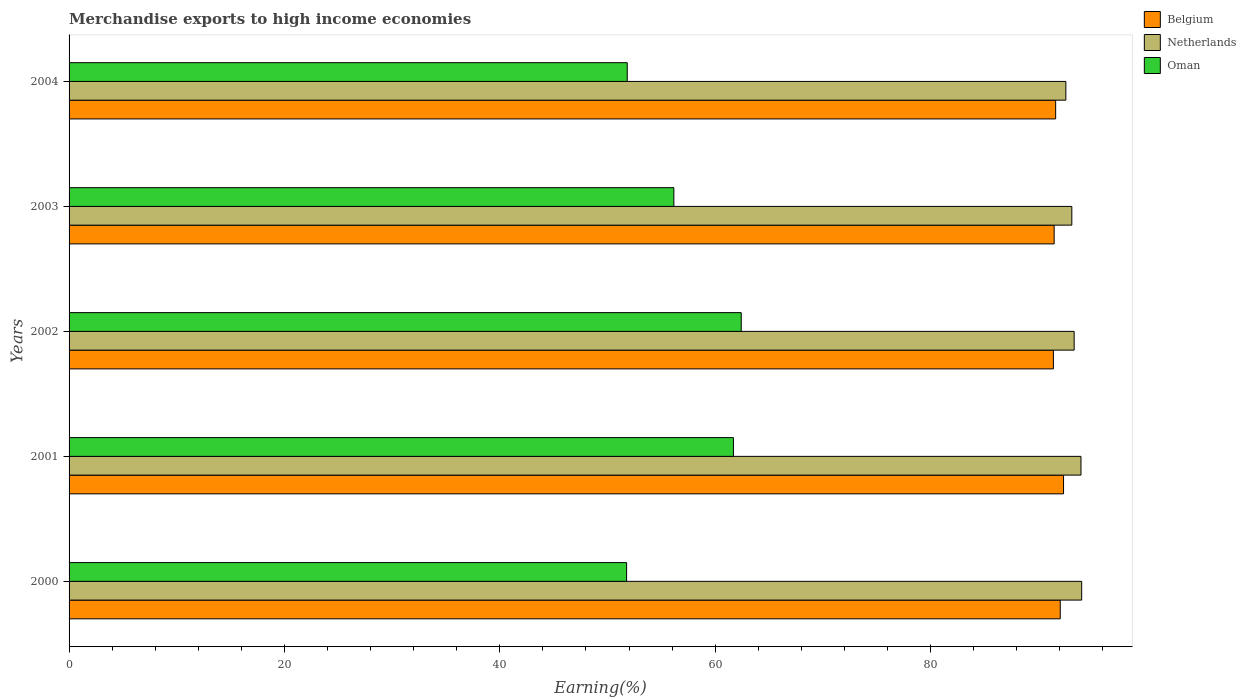How many groups of bars are there?
Offer a terse response. 5. Are the number of bars on each tick of the Y-axis equal?
Ensure brevity in your answer.  Yes. How many bars are there on the 4th tick from the bottom?
Offer a terse response. 3. What is the percentage of amount earned from merchandise exports in Belgium in 2003?
Provide a succinct answer. 91.47. Across all years, what is the maximum percentage of amount earned from merchandise exports in Oman?
Provide a short and direct response. 62.42. Across all years, what is the minimum percentage of amount earned from merchandise exports in Belgium?
Keep it short and to the point. 91.4. In which year was the percentage of amount earned from merchandise exports in Netherlands minimum?
Give a very brief answer. 2004. What is the total percentage of amount earned from merchandise exports in Oman in the graph?
Your answer should be very brief. 283.87. What is the difference between the percentage of amount earned from merchandise exports in Oman in 2000 and that in 2003?
Offer a terse response. -4.39. What is the difference between the percentage of amount earned from merchandise exports in Oman in 2000 and the percentage of amount earned from merchandise exports in Netherlands in 2001?
Your answer should be very brief. -42.19. What is the average percentage of amount earned from merchandise exports in Netherlands per year?
Your answer should be compact. 93.4. In the year 2004, what is the difference between the percentage of amount earned from merchandise exports in Netherlands and percentage of amount earned from merchandise exports in Belgium?
Provide a short and direct response. 0.95. In how many years, is the percentage of amount earned from merchandise exports in Oman greater than 28 %?
Provide a short and direct response. 5. What is the ratio of the percentage of amount earned from merchandise exports in Oman in 2003 to that in 2004?
Provide a succinct answer. 1.08. Is the percentage of amount earned from merchandise exports in Oman in 2000 less than that in 2003?
Provide a short and direct response. Yes. What is the difference between the highest and the second highest percentage of amount earned from merchandise exports in Netherlands?
Offer a very short reply. 0.07. What is the difference between the highest and the lowest percentage of amount earned from merchandise exports in Netherlands?
Your answer should be very brief. 1.47. In how many years, is the percentage of amount earned from merchandise exports in Belgium greater than the average percentage of amount earned from merchandise exports in Belgium taken over all years?
Offer a terse response. 2. Is the sum of the percentage of amount earned from merchandise exports in Belgium in 2003 and 2004 greater than the maximum percentage of amount earned from merchandise exports in Netherlands across all years?
Keep it short and to the point. Yes. What does the 1st bar from the top in 2000 represents?
Provide a succinct answer. Oman. What does the 2nd bar from the bottom in 2001 represents?
Provide a succinct answer. Netherlands. Is it the case that in every year, the sum of the percentage of amount earned from merchandise exports in Belgium and percentage of amount earned from merchandise exports in Netherlands is greater than the percentage of amount earned from merchandise exports in Oman?
Offer a terse response. Yes. How many bars are there?
Your answer should be very brief. 15. Are all the bars in the graph horizontal?
Ensure brevity in your answer.  Yes. How many years are there in the graph?
Offer a very short reply. 5. Are the values on the major ticks of X-axis written in scientific E-notation?
Make the answer very short. No. Does the graph contain any zero values?
Offer a terse response. No. Where does the legend appear in the graph?
Keep it short and to the point. Top right. How are the legend labels stacked?
Your answer should be compact. Vertical. What is the title of the graph?
Give a very brief answer. Merchandise exports to high income economies. Does "Bulgaria" appear as one of the legend labels in the graph?
Provide a short and direct response. No. What is the label or title of the X-axis?
Your response must be concise. Earning(%). What is the label or title of the Y-axis?
Your response must be concise. Years. What is the Earning(%) in Belgium in 2000?
Offer a very short reply. 92.04. What is the Earning(%) in Netherlands in 2000?
Ensure brevity in your answer.  94.03. What is the Earning(%) of Oman in 2000?
Provide a succinct answer. 51.77. What is the Earning(%) of Belgium in 2001?
Offer a very short reply. 92.35. What is the Earning(%) of Netherlands in 2001?
Provide a succinct answer. 93.96. What is the Earning(%) of Oman in 2001?
Provide a short and direct response. 61.69. What is the Earning(%) of Belgium in 2002?
Your response must be concise. 91.4. What is the Earning(%) of Netherlands in 2002?
Make the answer very short. 93.33. What is the Earning(%) of Oman in 2002?
Your answer should be compact. 62.42. What is the Earning(%) in Belgium in 2003?
Offer a terse response. 91.47. What is the Earning(%) of Netherlands in 2003?
Keep it short and to the point. 93.11. What is the Earning(%) of Oman in 2003?
Offer a very short reply. 56.16. What is the Earning(%) of Belgium in 2004?
Provide a succinct answer. 91.61. What is the Earning(%) of Netherlands in 2004?
Make the answer very short. 92.56. What is the Earning(%) of Oman in 2004?
Your answer should be very brief. 51.83. Across all years, what is the maximum Earning(%) of Belgium?
Make the answer very short. 92.35. Across all years, what is the maximum Earning(%) of Netherlands?
Offer a terse response. 94.03. Across all years, what is the maximum Earning(%) in Oman?
Keep it short and to the point. 62.42. Across all years, what is the minimum Earning(%) in Belgium?
Provide a short and direct response. 91.4. Across all years, what is the minimum Earning(%) in Netherlands?
Your answer should be very brief. 92.56. Across all years, what is the minimum Earning(%) of Oman?
Ensure brevity in your answer.  51.77. What is the total Earning(%) in Belgium in the graph?
Give a very brief answer. 458.87. What is the total Earning(%) of Netherlands in the graph?
Make the answer very short. 467. What is the total Earning(%) of Oman in the graph?
Your response must be concise. 283.87. What is the difference between the Earning(%) in Belgium in 2000 and that in 2001?
Make the answer very short. -0.31. What is the difference between the Earning(%) of Netherlands in 2000 and that in 2001?
Provide a succinct answer. 0.07. What is the difference between the Earning(%) of Oman in 2000 and that in 2001?
Provide a short and direct response. -9.92. What is the difference between the Earning(%) of Belgium in 2000 and that in 2002?
Give a very brief answer. 0.64. What is the difference between the Earning(%) in Netherlands in 2000 and that in 2002?
Provide a short and direct response. 0.7. What is the difference between the Earning(%) of Oman in 2000 and that in 2002?
Provide a short and direct response. -10.64. What is the difference between the Earning(%) in Belgium in 2000 and that in 2003?
Provide a short and direct response. 0.57. What is the difference between the Earning(%) of Netherlands in 2000 and that in 2003?
Ensure brevity in your answer.  0.92. What is the difference between the Earning(%) in Oman in 2000 and that in 2003?
Keep it short and to the point. -4.39. What is the difference between the Earning(%) of Belgium in 2000 and that in 2004?
Offer a terse response. 0.43. What is the difference between the Earning(%) in Netherlands in 2000 and that in 2004?
Ensure brevity in your answer.  1.47. What is the difference between the Earning(%) in Oman in 2000 and that in 2004?
Your answer should be compact. -0.06. What is the difference between the Earning(%) in Belgium in 2001 and that in 2002?
Your answer should be very brief. 0.94. What is the difference between the Earning(%) of Netherlands in 2001 and that in 2002?
Ensure brevity in your answer.  0.63. What is the difference between the Earning(%) in Oman in 2001 and that in 2002?
Offer a very short reply. -0.73. What is the difference between the Earning(%) in Belgium in 2001 and that in 2003?
Your response must be concise. 0.87. What is the difference between the Earning(%) in Netherlands in 2001 and that in 2003?
Provide a succinct answer. 0.85. What is the difference between the Earning(%) of Oman in 2001 and that in 2003?
Ensure brevity in your answer.  5.53. What is the difference between the Earning(%) in Belgium in 2001 and that in 2004?
Give a very brief answer. 0.73. What is the difference between the Earning(%) in Netherlands in 2001 and that in 2004?
Your answer should be compact. 1.4. What is the difference between the Earning(%) in Oman in 2001 and that in 2004?
Your response must be concise. 9.86. What is the difference between the Earning(%) in Belgium in 2002 and that in 2003?
Offer a terse response. -0.07. What is the difference between the Earning(%) in Netherlands in 2002 and that in 2003?
Give a very brief answer. 0.22. What is the difference between the Earning(%) of Oman in 2002 and that in 2003?
Provide a short and direct response. 6.26. What is the difference between the Earning(%) in Belgium in 2002 and that in 2004?
Your answer should be compact. -0.21. What is the difference between the Earning(%) in Netherlands in 2002 and that in 2004?
Your answer should be very brief. 0.77. What is the difference between the Earning(%) in Oman in 2002 and that in 2004?
Your response must be concise. 10.59. What is the difference between the Earning(%) in Belgium in 2003 and that in 2004?
Make the answer very short. -0.14. What is the difference between the Earning(%) in Netherlands in 2003 and that in 2004?
Provide a short and direct response. 0.55. What is the difference between the Earning(%) in Oman in 2003 and that in 2004?
Your answer should be very brief. 4.33. What is the difference between the Earning(%) of Belgium in 2000 and the Earning(%) of Netherlands in 2001?
Offer a very short reply. -1.92. What is the difference between the Earning(%) of Belgium in 2000 and the Earning(%) of Oman in 2001?
Your answer should be very brief. 30.35. What is the difference between the Earning(%) in Netherlands in 2000 and the Earning(%) in Oman in 2001?
Offer a terse response. 32.34. What is the difference between the Earning(%) in Belgium in 2000 and the Earning(%) in Netherlands in 2002?
Your answer should be very brief. -1.29. What is the difference between the Earning(%) in Belgium in 2000 and the Earning(%) in Oman in 2002?
Provide a succinct answer. 29.62. What is the difference between the Earning(%) in Netherlands in 2000 and the Earning(%) in Oman in 2002?
Provide a succinct answer. 31.61. What is the difference between the Earning(%) in Belgium in 2000 and the Earning(%) in Netherlands in 2003?
Keep it short and to the point. -1.07. What is the difference between the Earning(%) in Belgium in 2000 and the Earning(%) in Oman in 2003?
Provide a succinct answer. 35.88. What is the difference between the Earning(%) of Netherlands in 2000 and the Earning(%) of Oman in 2003?
Your answer should be compact. 37.87. What is the difference between the Earning(%) of Belgium in 2000 and the Earning(%) of Netherlands in 2004?
Your answer should be very brief. -0.52. What is the difference between the Earning(%) in Belgium in 2000 and the Earning(%) in Oman in 2004?
Offer a terse response. 40.21. What is the difference between the Earning(%) in Netherlands in 2000 and the Earning(%) in Oman in 2004?
Make the answer very short. 42.2. What is the difference between the Earning(%) of Belgium in 2001 and the Earning(%) of Netherlands in 2002?
Your answer should be very brief. -0.98. What is the difference between the Earning(%) in Belgium in 2001 and the Earning(%) in Oman in 2002?
Offer a terse response. 29.93. What is the difference between the Earning(%) in Netherlands in 2001 and the Earning(%) in Oman in 2002?
Provide a short and direct response. 31.55. What is the difference between the Earning(%) in Belgium in 2001 and the Earning(%) in Netherlands in 2003?
Offer a terse response. -0.77. What is the difference between the Earning(%) of Belgium in 2001 and the Earning(%) of Oman in 2003?
Give a very brief answer. 36.19. What is the difference between the Earning(%) in Netherlands in 2001 and the Earning(%) in Oman in 2003?
Offer a terse response. 37.8. What is the difference between the Earning(%) of Belgium in 2001 and the Earning(%) of Netherlands in 2004?
Provide a short and direct response. -0.21. What is the difference between the Earning(%) of Belgium in 2001 and the Earning(%) of Oman in 2004?
Offer a very short reply. 40.51. What is the difference between the Earning(%) in Netherlands in 2001 and the Earning(%) in Oman in 2004?
Offer a terse response. 42.13. What is the difference between the Earning(%) in Belgium in 2002 and the Earning(%) in Netherlands in 2003?
Offer a very short reply. -1.71. What is the difference between the Earning(%) of Belgium in 2002 and the Earning(%) of Oman in 2003?
Ensure brevity in your answer.  35.24. What is the difference between the Earning(%) of Netherlands in 2002 and the Earning(%) of Oman in 2003?
Offer a terse response. 37.17. What is the difference between the Earning(%) in Belgium in 2002 and the Earning(%) in Netherlands in 2004?
Give a very brief answer. -1.16. What is the difference between the Earning(%) of Belgium in 2002 and the Earning(%) of Oman in 2004?
Provide a short and direct response. 39.57. What is the difference between the Earning(%) in Netherlands in 2002 and the Earning(%) in Oman in 2004?
Your answer should be very brief. 41.5. What is the difference between the Earning(%) in Belgium in 2003 and the Earning(%) in Netherlands in 2004?
Keep it short and to the point. -1.09. What is the difference between the Earning(%) in Belgium in 2003 and the Earning(%) in Oman in 2004?
Give a very brief answer. 39.64. What is the difference between the Earning(%) in Netherlands in 2003 and the Earning(%) in Oman in 2004?
Ensure brevity in your answer.  41.28. What is the average Earning(%) in Belgium per year?
Your answer should be compact. 91.77. What is the average Earning(%) of Netherlands per year?
Offer a very short reply. 93.4. What is the average Earning(%) of Oman per year?
Ensure brevity in your answer.  56.77. In the year 2000, what is the difference between the Earning(%) in Belgium and Earning(%) in Netherlands?
Make the answer very short. -1.99. In the year 2000, what is the difference between the Earning(%) of Belgium and Earning(%) of Oman?
Keep it short and to the point. 40.27. In the year 2000, what is the difference between the Earning(%) in Netherlands and Earning(%) in Oman?
Offer a very short reply. 42.26. In the year 2001, what is the difference between the Earning(%) in Belgium and Earning(%) in Netherlands?
Offer a terse response. -1.62. In the year 2001, what is the difference between the Earning(%) in Belgium and Earning(%) in Oman?
Your answer should be compact. 30.66. In the year 2001, what is the difference between the Earning(%) in Netherlands and Earning(%) in Oman?
Provide a short and direct response. 32.27. In the year 2002, what is the difference between the Earning(%) of Belgium and Earning(%) of Netherlands?
Your answer should be very brief. -1.93. In the year 2002, what is the difference between the Earning(%) in Belgium and Earning(%) in Oman?
Offer a terse response. 28.99. In the year 2002, what is the difference between the Earning(%) of Netherlands and Earning(%) of Oman?
Give a very brief answer. 30.91. In the year 2003, what is the difference between the Earning(%) of Belgium and Earning(%) of Netherlands?
Provide a short and direct response. -1.64. In the year 2003, what is the difference between the Earning(%) of Belgium and Earning(%) of Oman?
Offer a very short reply. 35.31. In the year 2003, what is the difference between the Earning(%) in Netherlands and Earning(%) in Oman?
Give a very brief answer. 36.95. In the year 2004, what is the difference between the Earning(%) of Belgium and Earning(%) of Netherlands?
Your answer should be very brief. -0.95. In the year 2004, what is the difference between the Earning(%) in Belgium and Earning(%) in Oman?
Offer a very short reply. 39.78. In the year 2004, what is the difference between the Earning(%) in Netherlands and Earning(%) in Oman?
Your response must be concise. 40.73. What is the ratio of the Earning(%) of Belgium in 2000 to that in 2001?
Ensure brevity in your answer.  1. What is the ratio of the Earning(%) in Netherlands in 2000 to that in 2001?
Your answer should be compact. 1. What is the ratio of the Earning(%) in Oman in 2000 to that in 2001?
Your answer should be compact. 0.84. What is the ratio of the Earning(%) in Netherlands in 2000 to that in 2002?
Keep it short and to the point. 1.01. What is the ratio of the Earning(%) in Oman in 2000 to that in 2002?
Ensure brevity in your answer.  0.83. What is the ratio of the Earning(%) of Netherlands in 2000 to that in 2003?
Your answer should be very brief. 1.01. What is the ratio of the Earning(%) in Oman in 2000 to that in 2003?
Provide a short and direct response. 0.92. What is the ratio of the Earning(%) in Belgium in 2000 to that in 2004?
Offer a terse response. 1. What is the ratio of the Earning(%) of Netherlands in 2000 to that in 2004?
Provide a succinct answer. 1.02. What is the ratio of the Earning(%) of Oman in 2000 to that in 2004?
Make the answer very short. 1. What is the ratio of the Earning(%) in Belgium in 2001 to that in 2002?
Ensure brevity in your answer.  1.01. What is the ratio of the Earning(%) of Netherlands in 2001 to that in 2002?
Your response must be concise. 1.01. What is the ratio of the Earning(%) of Oman in 2001 to that in 2002?
Ensure brevity in your answer.  0.99. What is the ratio of the Earning(%) of Belgium in 2001 to that in 2003?
Offer a terse response. 1.01. What is the ratio of the Earning(%) of Netherlands in 2001 to that in 2003?
Give a very brief answer. 1.01. What is the ratio of the Earning(%) of Oman in 2001 to that in 2003?
Make the answer very short. 1.1. What is the ratio of the Earning(%) of Netherlands in 2001 to that in 2004?
Ensure brevity in your answer.  1.02. What is the ratio of the Earning(%) of Oman in 2001 to that in 2004?
Make the answer very short. 1.19. What is the ratio of the Earning(%) in Belgium in 2002 to that in 2003?
Ensure brevity in your answer.  1. What is the ratio of the Earning(%) of Oman in 2002 to that in 2003?
Your answer should be compact. 1.11. What is the ratio of the Earning(%) of Belgium in 2002 to that in 2004?
Your answer should be very brief. 1. What is the ratio of the Earning(%) of Netherlands in 2002 to that in 2004?
Your answer should be very brief. 1.01. What is the ratio of the Earning(%) in Oman in 2002 to that in 2004?
Make the answer very short. 1.2. What is the ratio of the Earning(%) in Netherlands in 2003 to that in 2004?
Provide a succinct answer. 1.01. What is the ratio of the Earning(%) of Oman in 2003 to that in 2004?
Give a very brief answer. 1.08. What is the difference between the highest and the second highest Earning(%) of Belgium?
Offer a terse response. 0.31. What is the difference between the highest and the second highest Earning(%) of Netherlands?
Your answer should be compact. 0.07. What is the difference between the highest and the second highest Earning(%) in Oman?
Give a very brief answer. 0.73. What is the difference between the highest and the lowest Earning(%) in Belgium?
Provide a short and direct response. 0.94. What is the difference between the highest and the lowest Earning(%) of Netherlands?
Your response must be concise. 1.47. What is the difference between the highest and the lowest Earning(%) in Oman?
Make the answer very short. 10.64. 